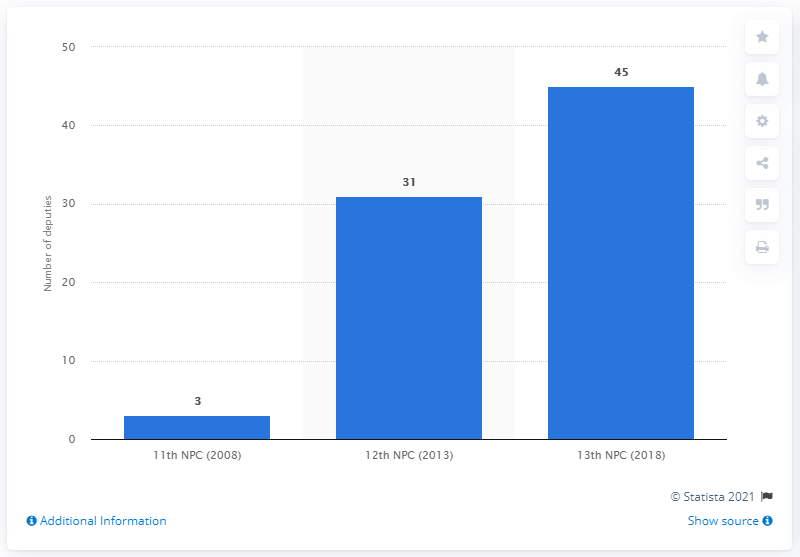Indicate a few pertinent items in this graphic. In 2018, the 13th National People's Congress allotted a total of 45 seats to migrant workers. 